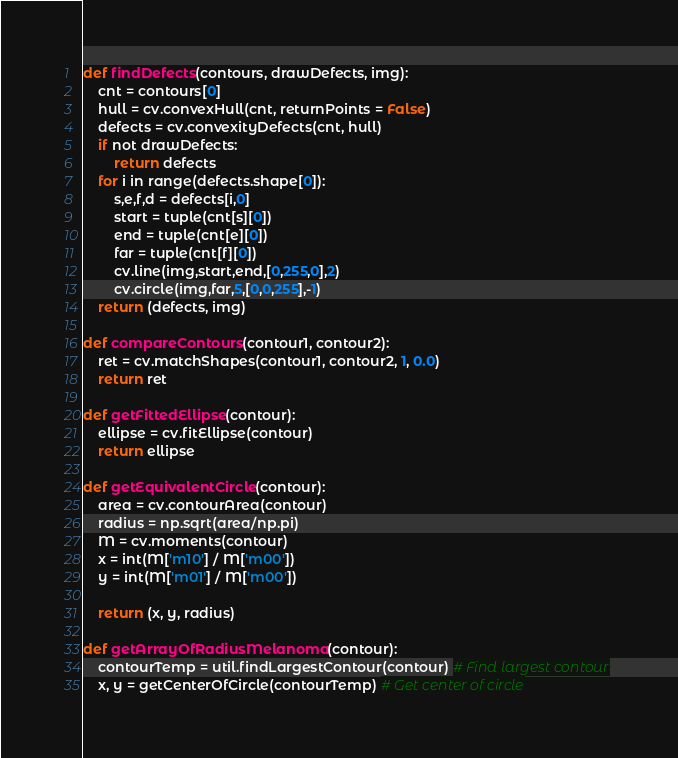<code> <loc_0><loc_0><loc_500><loc_500><_Python_>
def findDefects(contours, drawDefects, img):
	cnt = contours[0]
	hull = cv.convexHull(cnt, returnPoints = False)
	defects = cv.convexityDefects(cnt, hull)
	if not drawDefects:
		return defects
	for i in range(defects.shape[0]):
		s,e,f,d = defects[i,0]
		start = tuple(cnt[s][0])
		end = tuple(cnt[e][0])
		far = tuple(cnt[f][0])
		cv.line(img,start,end,[0,255,0],2)
		cv.circle(img,far,5,[0,0,255],-1)
	return (defects, img)

def compareContours(contour1, contour2):
	ret = cv.matchShapes(contour1, contour2, 1, 0.0)
	return ret

def getFittedEllipse(contour):
	ellipse = cv.fitEllipse(contour)
	return ellipse

def getEquivalentCircle(contour):
	area = cv.contourArea(contour)
	radius = np.sqrt(area/np.pi)
	M = cv.moments(contour)
	x = int(M['m10'] / M['m00'])
	y = int(M['m01'] / M['m00'])

	return (x, y, radius)

def getArrayOfRadiusMelanoma(contour):
	contourTemp = util.findLargestContour(contour) # Find largest contour
	x, y = getCenterOfCircle(contourTemp) # Get center of circle</code> 